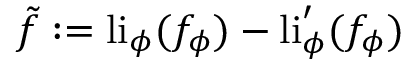Convert formula to latex. <formula><loc_0><loc_0><loc_500><loc_500>\tilde { f } \colon = l i _ { \phi } ( f _ { \phi } ) - l i _ { \phi } ^ { \prime } ( f _ { \phi } )</formula> 